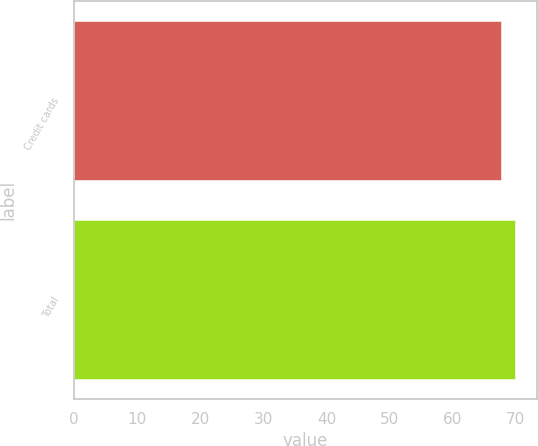Convert chart to OTSL. <chart><loc_0><loc_0><loc_500><loc_500><bar_chart><fcel>Credit cards<fcel>Total<nl><fcel>67.7<fcel>69.9<nl></chart> 